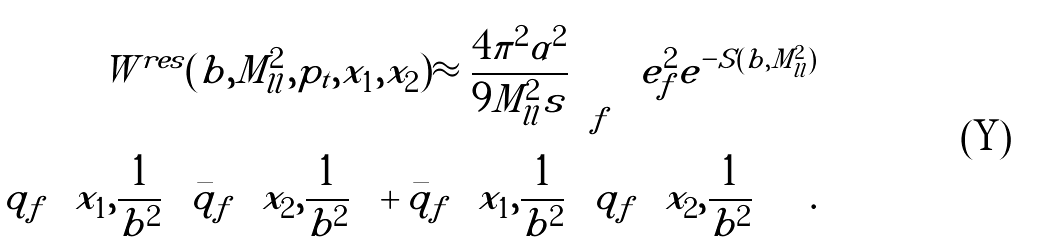Convert formula to latex. <formula><loc_0><loc_0><loc_500><loc_500>W ^ { r e s } ( b , M _ { l l } ^ { 2 } , p _ { t } , x _ { 1 } , x _ { 2 } ) \approx \frac { 4 \pi ^ { 2 } \alpha ^ { 2 } } { 9 M _ { l l } ^ { 2 } s } \sum _ { f } \, e _ { f } ^ { 2 } e ^ { - S ( b , M _ { l l } ^ { 2 } ) } \\ \left [ q _ { f } \left ( x _ { 1 } , \frac { 1 } { b ^ { 2 } } \right ) { \bar { q } } _ { f } \left ( x _ { 2 } , \frac { 1 } { b ^ { 2 } } \right ) + { \bar { q } } _ { f } \left ( x _ { 1 } , \frac { 1 } { b ^ { 2 } } \right ) q _ { f } \left ( x _ { 2 } , \frac { 1 } { b ^ { 2 } } \right ) \right ] \, .</formula> 